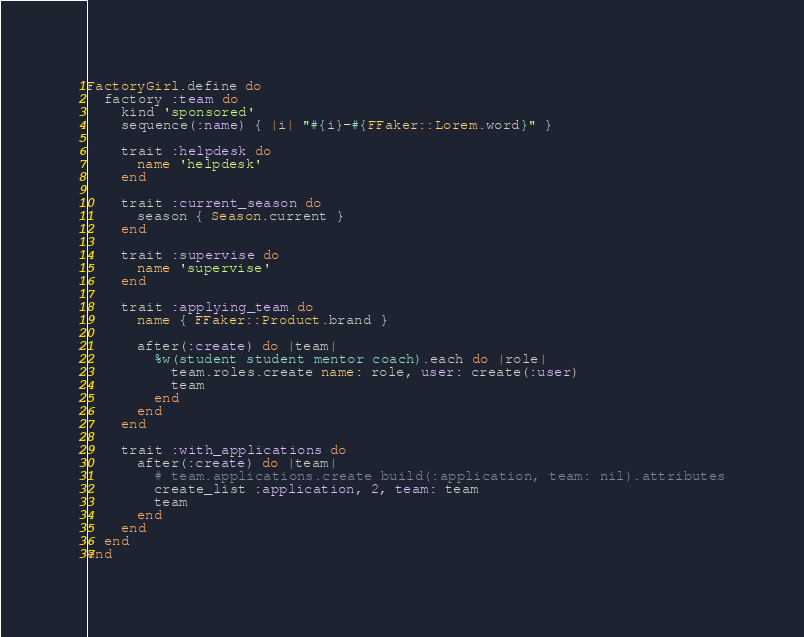<code> <loc_0><loc_0><loc_500><loc_500><_Ruby_>FactoryGirl.define do
  factory :team do
    kind 'sponsored'
    sequence(:name) { |i| "#{i}-#{FFaker::Lorem.word}" }

    trait :helpdesk do
      name 'helpdesk'
    end

    trait :current_season do
      season { Season.current }
    end

    trait :supervise do
      name 'supervise'
    end

    trait :applying_team do
      name { FFaker::Product.brand }

      after(:create) do |team|
        %w(student student mentor coach).each do |role|
          team.roles.create name: role, user: create(:user)
          team
        end
      end
    end

    trait :with_applications do
      after(:create) do |team|
        # team.applications.create build(:application, team: nil).attributes
        create_list :application, 2, team: team
        team
      end
    end
  end
end
</code> 